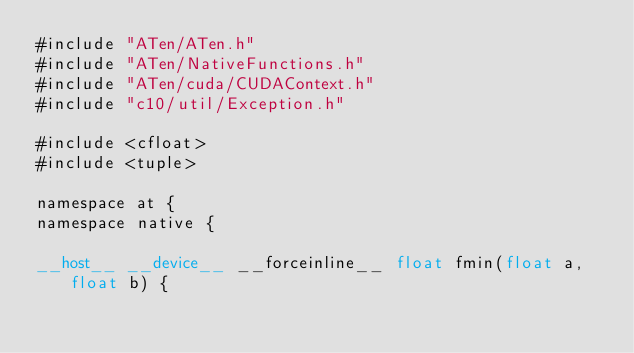Convert code to text. <code><loc_0><loc_0><loc_500><loc_500><_Cuda_>#include "ATen/ATen.h"
#include "ATen/NativeFunctions.h"
#include "ATen/cuda/CUDAContext.h"
#include "c10/util/Exception.h"

#include <cfloat>
#include <tuple>

namespace at {
namespace native {

__host__ __device__ __forceinline__ float fmin(float a, float b) {</code> 